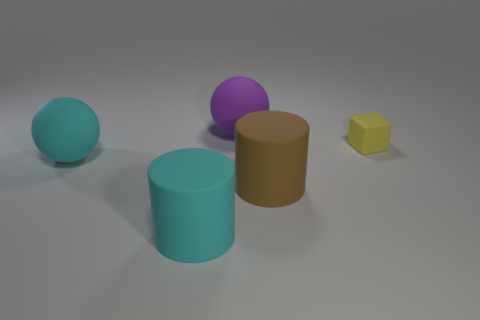How many other things are there of the same color as the tiny rubber cube?
Ensure brevity in your answer.  0. What shape is the cyan matte object behind the large brown object?
Make the answer very short. Sphere. Are there fewer purple rubber spheres than large blue spheres?
Your answer should be very brief. No. Is the material of the sphere in front of the purple matte thing the same as the yellow object?
Ensure brevity in your answer.  Yes. Are there any other things that have the same size as the purple thing?
Provide a short and direct response. Yes. There is a large purple thing; are there any large things behind it?
Give a very brief answer. No. There is a large matte cylinder that is right of the big ball behind the cyan ball that is in front of the tiny block; what is its color?
Offer a terse response. Brown. What is the shape of the brown thing that is the same size as the purple ball?
Keep it short and to the point. Cylinder. Are there more large purple matte things than balls?
Provide a short and direct response. No. Are there any large rubber cylinders that are behind the rubber ball in front of the big purple thing?
Provide a succinct answer. No. 